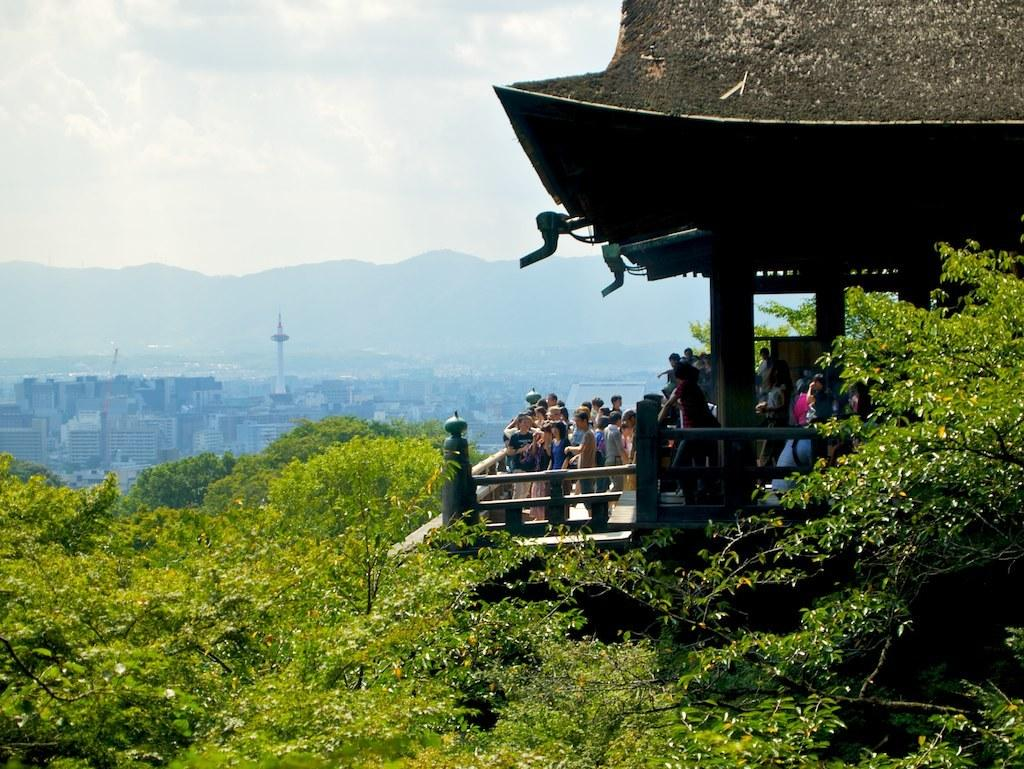What type of structures can be seen in the image? There are buildings in the image. What natural elements are present in the image? There are trees and a hill visible in the image. Where is the house located in the image? There appears to be a house on the right side of the image. What else can be seen in the image besides buildings and trees? There are people standing in the image. How would you describe the weather in the image? The sky is cloudy in the image. What type of oil is being used by the manager in the image? There is no manager or oil present in the image. What need does the house fulfill in the image? The house is a structure and does not fulfill a specific need in the image. 